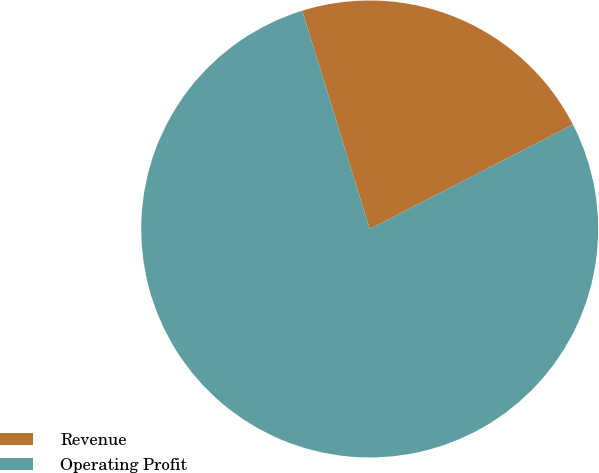Convert chart to OTSL. <chart><loc_0><loc_0><loc_500><loc_500><pie_chart><fcel>Revenue<fcel>Operating Profit<nl><fcel>22.22%<fcel>77.78%<nl></chart> 